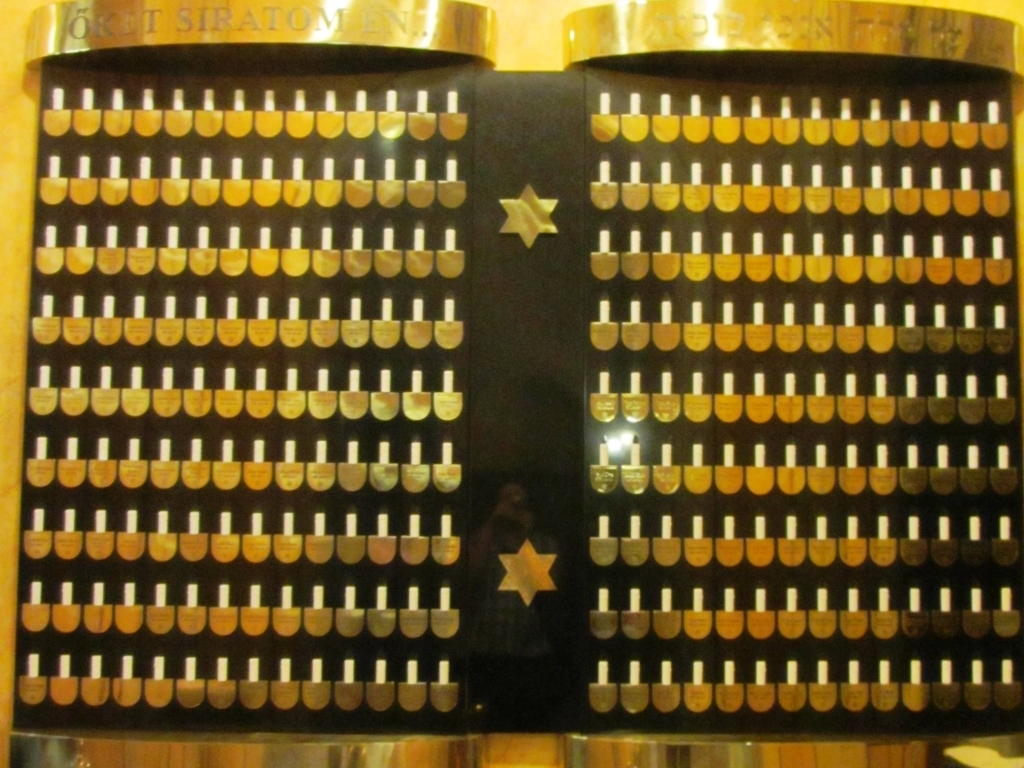How are the edges of the objects in this image? The edges of the objects in the image, which appear to be cylindrical keys or pegs on some sort of board, are rounded and smooth. These objects are arrayed in a grid-like pattern, suggesting they might be part of a mechanical device, possibly an antique or historical computing machine. 